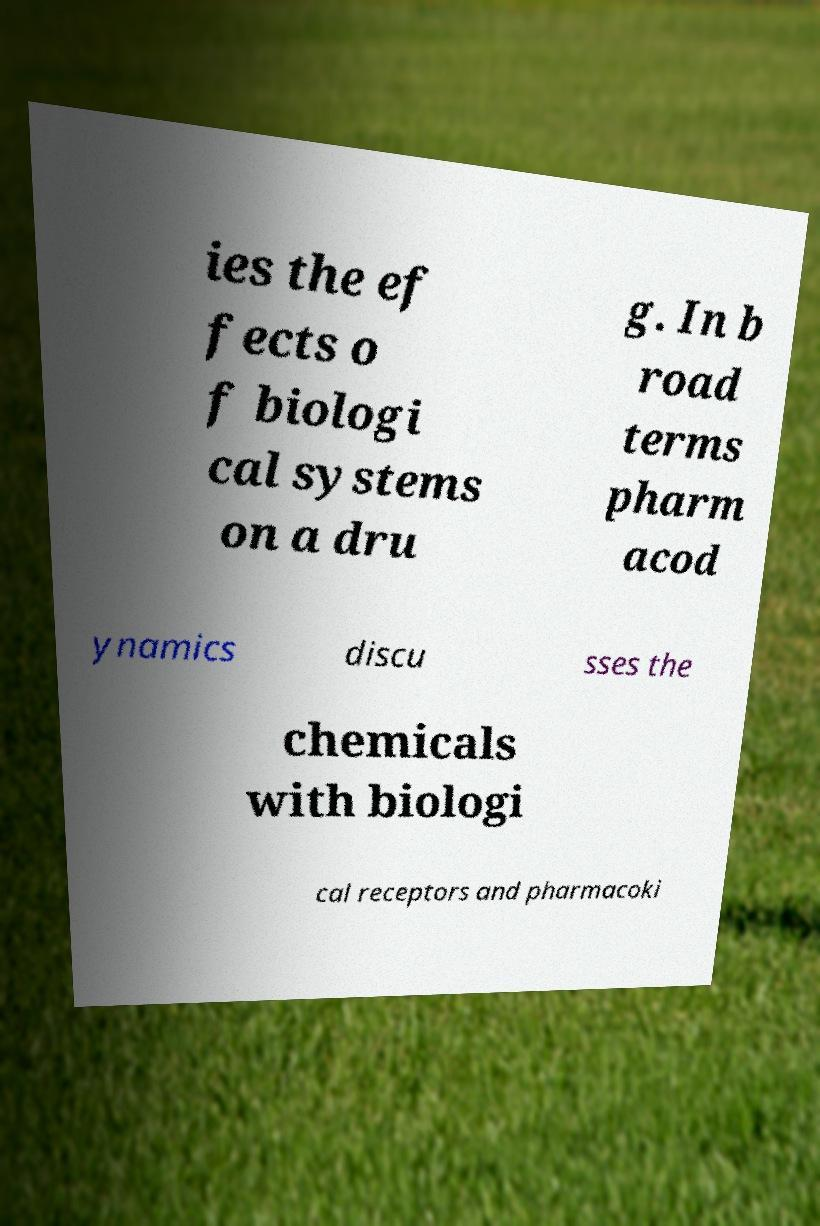I need the written content from this picture converted into text. Can you do that? ies the ef fects o f biologi cal systems on a dru g. In b road terms pharm acod ynamics discu sses the chemicals with biologi cal receptors and pharmacoki 